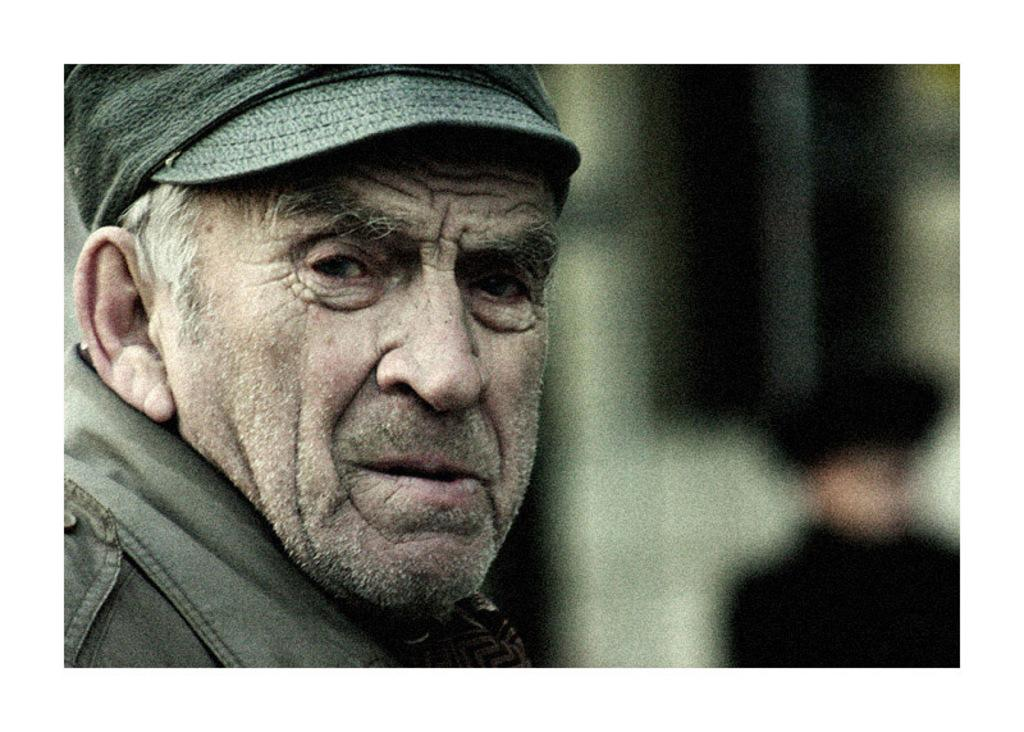What can be seen in the image? There is a person in the image. Can you describe the person's attire? The person is wearing a cap. What is the condition of the background in the image? The background of the image is blurred. What type of scent can be smelled in the image? There is no indication of a scent in the image, as it is a visual medium. 